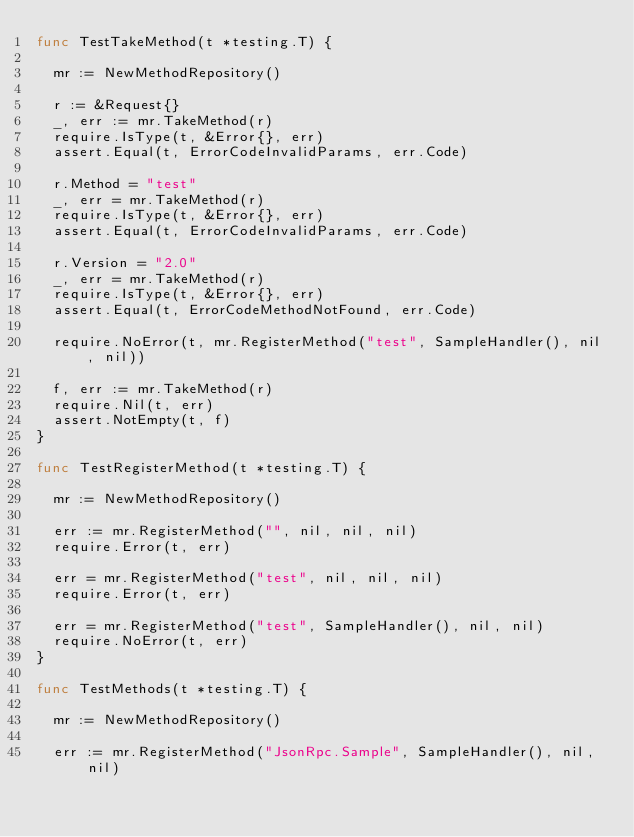<code> <loc_0><loc_0><loc_500><loc_500><_Go_>func TestTakeMethod(t *testing.T) {

	mr := NewMethodRepository()

	r := &Request{}
	_, err := mr.TakeMethod(r)
	require.IsType(t, &Error{}, err)
	assert.Equal(t, ErrorCodeInvalidParams, err.Code)

	r.Method = "test"
	_, err = mr.TakeMethod(r)
	require.IsType(t, &Error{}, err)
	assert.Equal(t, ErrorCodeInvalidParams, err.Code)

	r.Version = "2.0"
	_, err = mr.TakeMethod(r)
	require.IsType(t, &Error{}, err)
	assert.Equal(t, ErrorCodeMethodNotFound, err.Code)

	require.NoError(t, mr.RegisterMethod("test", SampleHandler(), nil, nil))

	f, err := mr.TakeMethod(r)
	require.Nil(t, err)
	assert.NotEmpty(t, f)
}

func TestRegisterMethod(t *testing.T) {

	mr := NewMethodRepository()

	err := mr.RegisterMethod("", nil, nil, nil)
	require.Error(t, err)

	err = mr.RegisterMethod("test", nil, nil, nil)
	require.Error(t, err)

	err = mr.RegisterMethod("test", SampleHandler(), nil, nil)
	require.NoError(t, err)
}

func TestMethods(t *testing.T) {

	mr := NewMethodRepository()

	err := mr.RegisterMethod("JsonRpc.Sample", SampleHandler(), nil, nil)</code> 